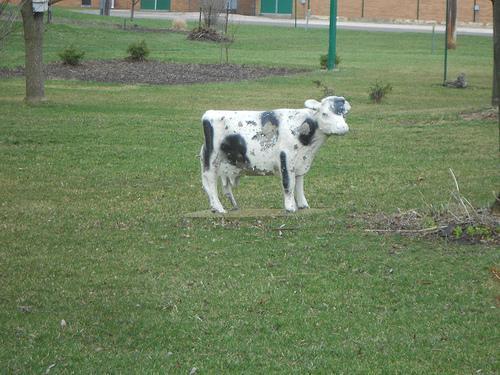How many statues are pictured?
Give a very brief answer. 1. 